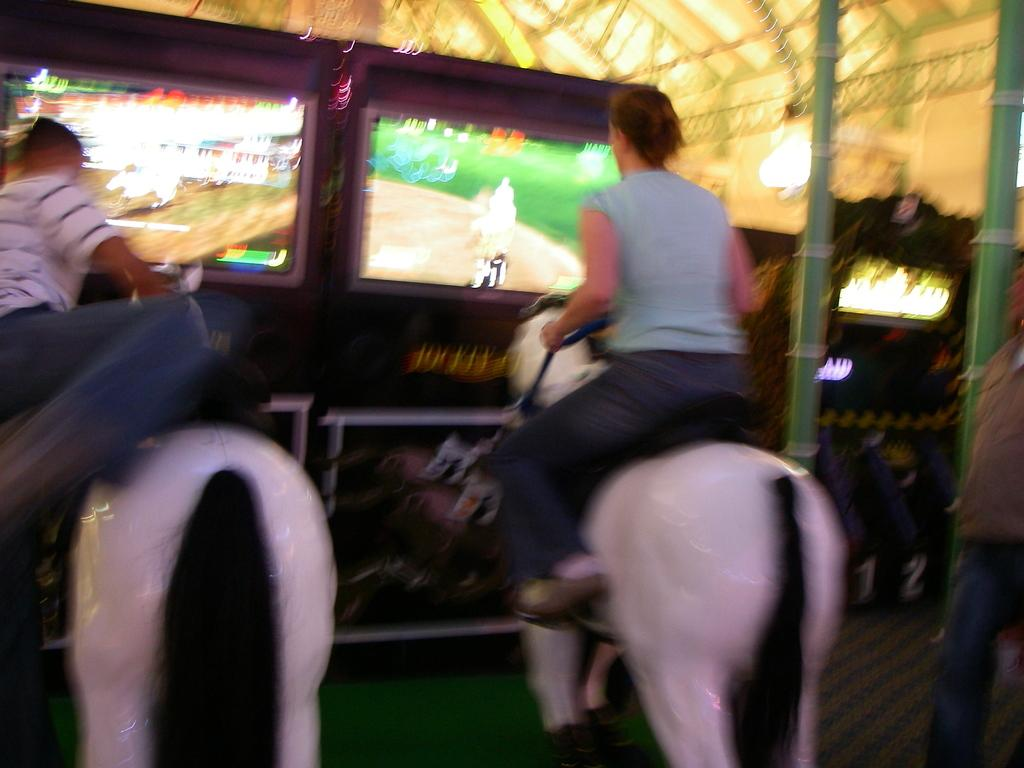What type of room is shown in the image? The image is taken in a gaming room. What toys are present in the image? There are two toy horses in the image. What are the children doing with the toy horses? Two children are sitting on the toy horses. What can be seen in front of the children? There are two screens in front of the children. What type of drink is being served in the afternoon in the image? There is no drink or indication of time of day in the image; it features two children sitting on toy horses in a gaming room. 